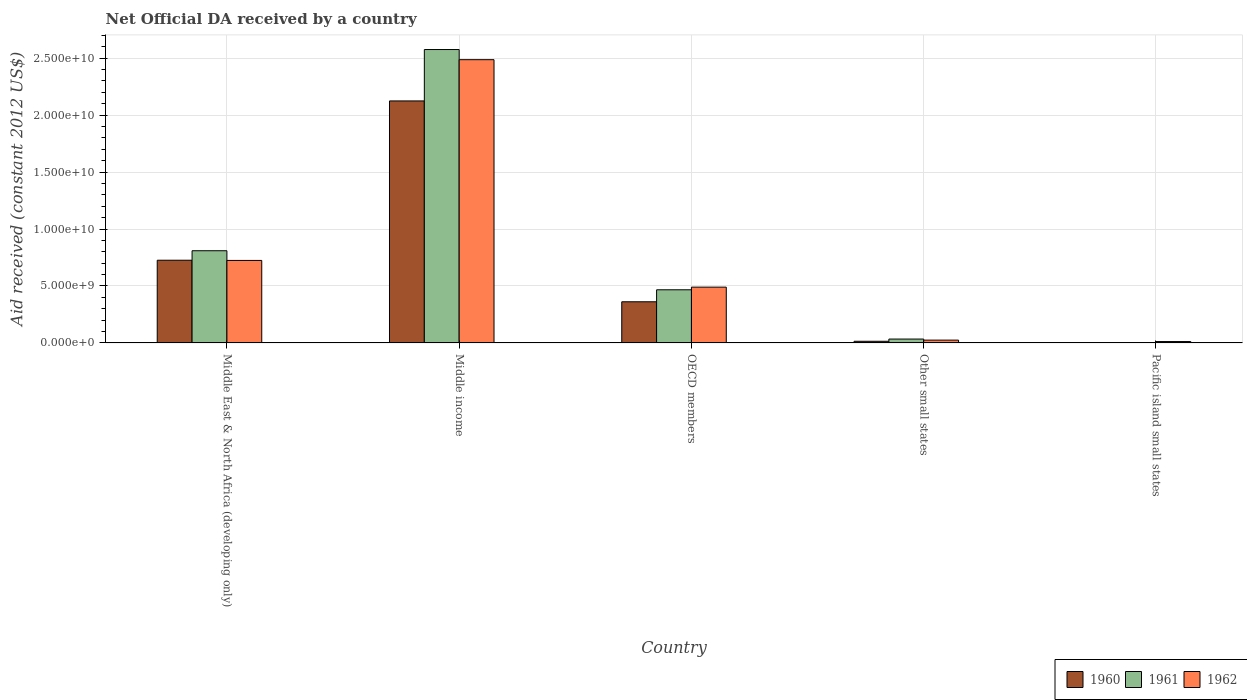Are the number of bars per tick equal to the number of legend labels?
Give a very brief answer. Yes. Are the number of bars on each tick of the X-axis equal?
Your answer should be very brief. Yes. How many bars are there on the 4th tick from the right?
Provide a succinct answer. 3. What is the label of the 2nd group of bars from the left?
Your answer should be very brief. Middle income. What is the net official development assistance aid received in 1960 in Middle East & North Africa (developing only)?
Give a very brief answer. 7.26e+09. Across all countries, what is the maximum net official development assistance aid received in 1960?
Offer a very short reply. 2.12e+1. Across all countries, what is the minimum net official development assistance aid received in 1960?
Your answer should be compact. 2.87e+07. In which country was the net official development assistance aid received in 1962 maximum?
Provide a short and direct response. Middle income. In which country was the net official development assistance aid received in 1960 minimum?
Your response must be concise. Pacific island small states. What is the total net official development assistance aid received in 1961 in the graph?
Keep it short and to the point. 3.89e+1. What is the difference between the net official development assistance aid received in 1960 in OECD members and that in Pacific island small states?
Give a very brief answer. 3.58e+09. What is the difference between the net official development assistance aid received in 1960 in Middle income and the net official development assistance aid received in 1961 in OECD members?
Provide a short and direct response. 1.66e+1. What is the average net official development assistance aid received in 1960 per country?
Keep it short and to the point. 6.46e+09. What is the difference between the net official development assistance aid received of/in 1960 and net official development assistance aid received of/in 1962 in Pacific island small states?
Your response must be concise. -9.36e+07. What is the ratio of the net official development assistance aid received in 1962 in Middle East & North Africa (developing only) to that in Pacific island small states?
Offer a very short reply. 59.23. What is the difference between the highest and the second highest net official development assistance aid received in 1960?
Give a very brief answer. 1.40e+1. What is the difference between the highest and the lowest net official development assistance aid received in 1961?
Keep it short and to the point. 2.57e+1. What does the 1st bar from the left in Pacific island small states represents?
Keep it short and to the point. 1960. Is it the case that in every country, the sum of the net official development assistance aid received in 1962 and net official development assistance aid received in 1960 is greater than the net official development assistance aid received in 1961?
Offer a terse response. Yes. How many bars are there?
Ensure brevity in your answer.  15. Does the graph contain grids?
Offer a terse response. Yes. What is the title of the graph?
Make the answer very short. Net Official DA received by a country. What is the label or title of the Y-axis?
Keep it short and to the point. Aid received (constant 2012 US$). What is the Aid received (constant 2012 US$) of 1960 in Middle East & North Africa (developing only)?
Your response must be concise. 7.26e+09. What is the Aid received (constant 2012 US$) of 1961 in Middle East & North Africa (developing only)?
Your answer should be compact. 8.09e+09. What is the Aid received (constant 2012 US$) of 1962 in Middle East & North Africa (developing only)?
Offer a terse response. 7.24e+09. What is the Aid received (constant 2012 US$) of 1960 in Middle income?
Give a very brief answer. 2.12e+1. What is the Aid received (constant 2012 US$) of 1961 in Middle income?
Make the answer very short. 2.58e+1. What is the Aid received (constant 2012 US$) in 1962 in Middle income?
Offer a terse response. 2.49e+1. What is the Aid received (constant 2012 US$) of 1960 in OECD members?
Ensure brevity in your answer.  3.61e+09. What is the Aid received (constant 2012 US$) of 1961 in OECD members?
Offer a terse response. 4.67e+09. What is the Aid received (constant 2012 US$) in 1962 in OECD members?
Provide a succinct answer. 4.90e+09. What is the Aid received (constant 2012 US$) of 1960 in Other small states?
Your answer should be very brief. 1.46e+08. What is the Aid received (constant 2012 US$) in 1961 in Other small states?
Keep it short and to the point. 3.41e+08. What is the Aid received (constant 2012 US$) of 1962 in Other small states?
Your answer should be compact. 2.48e+08. What is the Aid received (constant 2012 US$) in 1960 in Pacific island small states?
Your answer should be compact. 2.87e+07. What is the Aid received (constant 2012 US$) of 1961 in Pacific island small states?
Ensure brevity in your answer.  3.25e+07. What is the Aid received (constant 2012 US$) of 1962 in Pacific island small states?
Provide a short and direct response. 1.22e+08. Across all countries, what is the maximum Aid received (constant 2012 US$) of 1960?
Keep it short and to the point. 2.12e+1. Across all countries, what is the maximum Aid received (constant 2012 US$) of 1961?
Give a very brief answer. 2.58e+1. Across all countries, what is the maximum Aid received (constant 2012 US$) of 1962?
Make the answer very short. 2.49e+1. Across all countries, what is the minimum Aid received (constant 2012 US$) in 1960?
Offer a very short reply. 2.87e+07. Across all countries, what is the minimum Aid received (constant 2012 US$) of 1961?
Offer a very short reply. 3.25e+07. Across all countries, what is the minimum Aid received (constant 2012 US$) in 1962?
Your response must be concise. 1.22e+08. What is the total Aid received (constant 2012 US$) of 1960 in the graph?
Offer a terse response. 3.23e+1. What is the total Aid received (constant 2012 US$) in 1961 in the graph?
Offer a terse response. 3.89e+1. What is the total Aid received (constant 2012 US$) of 1962 in the graph?
Your response must be concise. 3.74e+1. What is the difference between the Aid received (constant 2012 US$) in 1960 in Middle East & North Africa (developing only) and that in Middle income?
Make the answer very short. -1.40e+1. What is the difference between the Aid received (constant 2012 US$) in 1961 in Middle East & North Africa (developing only) and that in Middle income?
Your response must be concise. -1.77e+1. What is the difference between the Aid received (constant 2012 US$) of 1962 in Middle East & North Africa (developing only) and that in Middle income?
Your answer should be compact. -1.76e+1. What is the difference between the Aid received (constant 2012 US$) in 1960 in Middle East & North Africa (developing only) and that in OECD members?
Provide a succinct answer. 3.65e+09. What is the difference between the Aid received (constant 2012 US$) in 1961 in Middle East & North Africa (developing only) and that in OECD members?
Ensure brevity in your answer.  3.43e+09. What is the difference between the Aid received (constant 2012 US$) of 1962 in Middle East & North Africa (developing only) and that in OECD members?
Ensure brevity in your answer.  2.34e+09. What is the difference between the Aid received (constant 2012 US$) of 1960 in Middle East & North Africa (developing only) and that in Other small states?
Make the answer very short. 7.11e+09. What is the difference between the Aid received (constant 2012 US$) in 1961 in Middle East & North Africa (developing only) and that in Other small states?
Keep it short and to the point. 7.75e+09. What is the difference between the Aid received (constant 2012 US$) of 1962 in Middle East & North Africa (developing only) and that in Other small states?
Provide a short and direct response. 6.99e+09. What is the difference between the Aid received (constant 2012 US$) of 1960 in Middle East & North Africa (developing only) and that in Pacific island small states?
Offer a very short reply. 7.23e+09. What is the difference between the Aid received (constant 2012 US$) in 1961 in Middle East & North Africa (developing only) and that in Pacific island small states?
Make the answer very short. 8.06e+09. What is the difference between the Aid received (constant 2012 US$) in 1962 in Middle East & North Africa (developing only) and that in Pacific island small states?
Provide a short and direct response. 7.12e+09. What is the difference between the Aid received (constant 2012 US$) of 1960 in Middle income and that in OECD members?
Give a very brief answer. 1.76e+1. What is the difference between the Aid received (constant 2012 US$) in 1961 in Middle income and that in OECD members?
Your answer should be very brief. 2.11e+1. What is the difference between the Aid received (constant 2012 US$) of 1962 in Middle income and that in OECD members?
Provide a short and direct response. 2.00e+1. What is the difference between the Aid received (constant 2012 US$) of 1960 in Middle income and that in Other small states?
Provide a short and direct response. 2.11e+1. What is the difference between the Aid received (constant 2012 US$) in 1961 in Middle income and that in Other small states?
Your answer should be compact. 2.54e+1. What is the difference between the Aid received (constant 2012 US$) of 1962 in Middle income and that in Other small states?
Provide a short and direct response. 2.46e+1. What is the difference between the Aid received (constant 2012 US$) of 1960 in Middle income and that in Pacific island small states?
Give a very brief answer. 2.12e+1. What is the difference between the Aid received (constant 2012 US$) in 1961 in Middle income and that in Pacific island small states?
Keep it short and to the point. 2.57e+1. What is the difference between the Aid received (constant 2012 US$) in 1962 in Middle income and that in Pacific island small states?
Your response must be concise. 2.47e+1. What is the difference between the Aid received (constant 2012 US$) in 1960 in OECD members and that in Other small states?
Provide a short and direct response. 3.47e+09. What is the difference between the Aid received (constant 2012 US$) in 1961 in OECD members and that in Other small states?
Keep it short and to the point. 4.32e+09. What is the difference between the Aid received (constant 2012 US$) of 1962 in OECD members and that in Other small states?
Offer a very short reply. 4.65e+09. What is the difference between the Aid received (constant 2012 US$) in 1960 in OECD members and that in Pacific island small states?
Your answer should be compact. 3.58e+09. What is the difference between the Aid received (constant 2012 US$) in 1961 in OECD members and that in Pacific island small states?
Make the answer very short. 4.63e+09. What is the difference between the Aid received (constant 2012 US$) of 1962 in OECD members and that in Pacific island small states?
Keep it short and to the point. 4.78e+09. What is the difference between the Aid received (constant 2012 US$) in 1960 in Other small states and that in Pacific island small states?
Your answer should be compact. 1.17e+08. What is the difference between the Aid received (constant 2012 US$) in 1961 in Other small states and that in Pacific island small states?
Give a very brief answer. 3.09e+08. What is the difference between the Aid received (constant 2012 US$) of 1962 in Other small states and that in Pacific island small states?
Offer a very short reply. 1.26e+08. What is the difference between the Aid received (constant 2012 US$) in 1960 in Middle East & North Africa (developing only) and the Aid received (constant 2012 US$) in 1961 in Middle income?
Keep it short and to the point. -1.85e+1. What is the difference between the Aid received (constant 2012 US$) in 1960 in Middle East & North Africa (developing only) and the Aid received (constant 2012 US$) in 1962 in Middle income?
Offer a very short reply. -1.76e+1. What is the difference between the Aid received (constant 2012 US$) in 1961 in Middle East & North Africa (developing only) and the Aid received (constant 2012 US$) in 1962 in Middle income?
Give a very brief answer. -1.68e+1. What is the difference between the Aid received (constant 2012 US$) of 1960 in Middle East & North Africa (developing only) and the Aid received (constant 2012 US$) of 1961 in OECD members?
Provide a succinct answer. 2.59e+09. What is the difference between the Aid received (constant 2012 US$) of 1960 in Middle East & North Africa (developing only) and the Aid received (constant 2012 US$) of 1962 in OECD members?
Your answer should be very brief. 2.36e+09. What is the difference between the Aid received (constant 2012 US$) of 1961 in Middle East & North Africa (developing only) and the Aid received (constant 2012 US$) of 1962 in OECD members?
Your response must be concise. 3.19e+09. What is the difference between the Aid received (constant 2012 US$) in 1960 in Middle East & North Africa (developing only) and the Aid received (constant 2012 US$) in 1961 in Other small states?
Offer a terse response. 6.92e+09. What is the difference between the Aid received (constant 2012 US$) in 1960 in Middle East & North Africa (developing only) and the Aid received (constant 2012 US$) in 1962 in Other small states?
Your response must be concise. 7.01e+09. What is the difference between the Aid received (constant 2012 US$) in 1961 in Middle East & North Africa (developing only) and the Aid received (constant 2012 US$) in 1962 in Other small states?
Keep it short and to the point. 7.84e+09. What is the difference between the Aid received (constant 2012 US$) of 1960 in Middle East & North Africa (developing only) and the Aid received (constant 2012 US$) of 1961 in Pacific island small states?
Provide a short and direct response. 7.23e+09. What is the difference between the Aid received (constant 2012 US$) of 1960 in Middle East & North Africa (developing only) and the Aid received (constant 2012 US$) of 1962 in Pacific island small states?
Keep it short and to the point. 7.14e+09. What is the difference between the Aid received (constant 2012 US$) in 1961 in Middle East & North Africa (developing only) and the Aid received (constant 2012 US$) in 1962 in Pacific island small states?
Your response must be concise. 7.97e+09. What is the difference between the Aid received (constant 2012 US$) in 1960 in Middle income and the Aid received (constant 2012 US$) in 1961 in OECD members?
Make the answer very short. 1.66e+1. What is the difference between the Aid received (constant 2012 US$) of 1960 in Middle income and the Aid received (constant 2012 US$) of 1962 in OECD members?
Offer a very short reply. 1.63e+1. What is the difference between the Aid received (constant 2012 US$) in 1961 in Middle income and the Aid received (constant 2012 US$) in 1962 in OECD members?
Keep it short and to the point. 2.09e+1. What is the difference between the Aid received (constant 2012 US$) in 1960 in Middle income and the Aid received (constant 2012 US$) in 1961 in Other small states?
Your answer should be very brief. 2.09e+1. What is the difference between the Aid received (constant 2012 US$) of 1960 in Middle income and the Aid received (constant 2012 US$) of 1962 in Other small states?
Your response must be concise. 2.10e+1. What is the difference between the Aid received (constant 2012 US$) of 1961 in Middle income and the Aid received (constant 2012 US$) of 1962 in Other small states?
Ensure brevity in your answer.  2.55e+1. What is the difference between the Aid received (constant 2012 US$) of 1960 in Middle income and the Aid received (constant 2012 US$) of 1961 in Pacific island small states?
Your answer should be very brief. 2.12e+1. What is the difference between the Aid received (constant 2012 US$) of 1960 in Middle income and the Aid received (constant 2012 US$) of 1962 in Pacific island small states?
Ensure brevity in your answer.  2.11e+1. What is the difference between the Aid received (constant 2012 US$) in 1961 in Middle income and the Aid received (constant 2012 US$) in 1962 in Pacific island small states?
Provide a short and direct response. 2.56e+1. What is the difference between the Aid received (constant 2012 US$) of 1960 in OECD members and the Aid received (constant 2012 US$) of 1961 in Other small states?
Keep it short and to the point. 3.27e+09. What is the difference between the Aid received (constant 2012 US$) in 1960 in OECD members and the Aid received (constant 2012 US$) in 1962 in Other small states?
Provide a short and direct response. 3.36e+09. What is the difference between the Aid received (constant 2012 US$) in 1961 in OECD members and the Aid received (constant 2012 US$) in 1962 in Other small states?
Ensure brevity in your answer.  4.42e+09. What is the difference between the Aid received (constant 2012 US$) of 1960 in OECD members and the Aid received (constant 2012 US$) of 1961 in Pacific island small states?
Offer a terse response. 3.58e+09. What is the difference between the Aid received (constant 2012 US$) of 1960 in OECD members and the Aid received (constant 2012 US$) of 1962 in Pacific island small states?
Offer a terse response. 3.49e+09. What is the difference between the Aid received (constant 2012 US$) of 1961 in OECD members and the Aid received (constant 2012 US$) of 1962 in Pacific island small states?
Provide a succinct answer. 4.54e+09. What is the difference between the Aid received (constant 2012 US$) in 1960 in Other small states and the Aid received (constant 2012 US$) in 1961 in Pacific island small states?
Your response must be concise. 1.14e+08. What is the difference between the Aid received (constant 2012 US$) in 1960 in Other small states and the Aid received (constant 2012 US$) in 1962 in Pacific island small states?
Your answer should be very brief. 2.39e+07. What is the difference between the Aid received (constant 2012 US$) of 1961 in Other small states and the Aid received (constant 2012 US$) of 1962 in Pacific island small states?
Provide a short and direct response. 2.19e+08. What is the average Aid received (constant 2012 US$) of 1960 per country?
Provide a short and direct response. 6.46e+09. What is the average Aid received (constant 2012 US$) in 1961 per country?
Ensure brevity in your answer.  7.78e+09. What is the average Aid received (constant 2012 US$) of 1962 per country?
Your response must be concise. 7.47e+09. What is the difference between the Aid received (constant 2012 US$) of 1960 and Aid received (constant 2012 US$) of 1961 in Middle East & North Africa (developing only)?
Your answer should be compact. -8.32e+08. What is the difference between the Aid received (constant 2012 US$) of 1960 and Aid received (constant 2012 US$) of 1962 in Middle East & North Africa (developing only)?
Provide a short and direct response. 1.81e+07. What is the difference between the Aid received (constant 2012 US$) of 1961 and Aid received (constant 2012 US$) of 1962 in Middle East & North Africa (developing only)?
Keep it short and to the point. 8.50e+08. What is the difference between the Aid received (constant 2012 US$) of 1960 and Aid received (constant 2012 US$) of 1961 in Middle income?
Give a very brief answer. -4.51e+09. What is the difference between the Aid received (constant 2012 US$) of 1960 and Aid received (constant 2012 US$) of 1962 in Middle income?
Your answer should be very brief. -3.62e+09. What is the difference between the Aid received (constant 2012 US$) of 1961 and Aid received (constant 2012 US$) of 1962 in Middle income?
Your answer should be very brief. 8.89e+08. What is the difference between the Aid received (constant 2012 US$) of 1960 and Aid received (constant 2012 US$) of 1961 in OECD members?
Keep it short and to the point. -1.05e+09. What is the difference between the Aid received (constant 2012 US$) in 1960 and Aid received (constant 2012 US$) in 1962 in OECD members?
Your response must be concise. -1.28e+09. What is the difference between the Aid received (constant 2012 US$) of 1961 and Aid received (constant 2012 US$) of 1962 in OECD members?
Give a very brief answer. -2.32e+08. What is the difference between the Aid received (constant 2012 US$) in 1960 and Aid received (constant 2012 US$) in 1961 in Other small states?
Your response must be concise. -1.95e+08. What is the difference between the Aid received (constant 2012 US$) of 1960 and Aid received (constant 2012 US$) of 1962 in Other small states?
Make the answer very short. -1.02e+08. What is the difference between the Aid received (constant 2012 US$) in 1961 and Aid received (constant 2012 US$) in 1962 in Other small states?
Provide a short and direct response. 9.32e+07. What is the difference between the Aid received (constant 2012 US$) in 1960 and Aid received (constant 2012 US$) in 1961 in Pacific island small states?
Provide a short and direct response. -3.76e+06. What is the difference between the Aid received (constant 2012 US$) in 1960 and Aid received (constant 2012 US$) in 1962 in Pacific island small states?
Your answer should be very brief. -9.36e+07. What is the difference between the Aid received (constant 2012 US$) of 1961 and Aid received (constant 2012 US$) of 1962 in Pacific island small states?
Keep it short and to the point. -8.98e+07. What is the ratio of the Aid received (constant 2012 US$) of 1960 in Middle East & North Africa (developing only) to that in Middle income?
Offer a terse response. 0.34. What is the ratio of the Aid received (constant 2012 US$) in 1961 in Middle East & North Africa (developing only) to that in Middle income?
Provide a succinct answer. 0.31. What is the ratio of the Aid received (constant 2012 US$) of 1962 in Middle East & North Africa (developing only) to that in Middle income?
Ensure brevity in your answer.  0.29. What is the ratio of the Aid received (constant 2012 US$) in 1960 in Middle East & North Africa (developing only) to that in OECD members?
Provide a short and direct response. 2.01. What is the ratio of the Aid received (constant 2012 US$) in 1961 in Middle East & North Africa (developing only) to that in OECD members?
Provide a succinct answer. 1.73. What is the ratio of the Aid received (constant 2012 US$) in 1962 in Middle East & North Africa (developing only) to that in OECD members?
Ensure brevity in your answer.  1.48. What is the ratio of the Aid received (constant 2012 US$) in 1960 in Middle East & North Africa (developing only) to that in Other small states?
Ensure brevity in your answer.  49.68. What is the ratio of the Aid received (constant 2012 US$) in 1961 in Middle East & North Africa (developing only) to that in Other small states?
Your response must be concise. 23.7. What is the ratio of the Aid received (constant 2012 US$) of 1962 in Middle East & North Africa (developing only) to that in Other small states?
Offer a terse response. 29.18. What is the ratio of the Aid received (constant 2012 US$) in 1960 in Middle East & North Africa (developing only) to that in Pacific island small states?
Provide a short and direct response. 252.89. What is the ratio of the Aid received (constant 2012 US$) in 1961 in Middle East & North Africa (developing only) to that in Pacific island small states?
Provide a short and direct response. 249.23. What is the ratio of the Aid received (constant 2012 US$) of 1962 in Middle East & North Africa (developing only) to that in Pacific island small states?
Give a very brief answer. 59.23. What is the ratio of the Aid received (constant 2012 US$) of 1960 in Middle income to that in OECD members?
Your response must be concise. 5.88. What is the ratio of the Aid received (constant 2012 US$) of 1961 in Middle income to that in OECD members?
Your response must be concise. 5.52. What is the ratio of the Aid received (constant 2012 US$) of 1962 in Middle income to that in OECD members?
Make the answer very short. 5.08. What is the ratio of the Aid received (constant 2012 US$) in 1960 in Middle income to that in Other small states?
Your answer should be very brief. 145.35. What is the ratio of the Aid received (constant 2012 US$) of 1961 in Middle income to that in Other small states?
Provide a short and direct response. 75.42. What is the ratio of the Aid received (constant 2012 US$) of 1962 in Middle income to that in Other small states?
Offer a very short reply. 100.17. What is the ratio of the Aid received (constant 2012 US$) in 1960 in Middle income to that in Pacific island small states?
Your answer should be compact. 739.85. What is the ratio of the Aid received (constant 2012 US$) of 1961 in Middle income to that in Pacific island small states?
Your response must be concise. 793.09. What is the ratio of the Aid received (constant 2012 US$) in 1962 in Middle income to that in Pacific island small states?
Offer a very short reply. 203.34. What is the ratio of the Aid received (constant 2012 US$) in 1960 in OECD members to that in Other small states?
Ensure brevity in your answer.  24.72. What is the ratio of the Aid received (constant 2012 US$) in 1961 in OECD members to that in Other small states?
Your response must be concise. 13.66. What is the ratio of the Aid received (constant 2012 US$) in 1962 in OECD members to that in Other small states?
Your response must be concise. 19.73. What is the ratio of the Aid received (constant 2012 US$) of 1960 in OECD members to that in Pacific island small states?
Your answer should be compact. 125.84. What is the ratio of the Aid received (constant 2012 US$) of 1961 in OECD members to that in Pacific island small states?
Offer a very short reply. 143.69. What is the ratio of the Aid received (constant 2012 US$) of 1962 in OECD members to that in Pacific island small states?
Your answer should be compact. 40.06. What is the ratio of the Aid received (constant 2012 US$) of 1960 in Other small states to that in Pacific island small states?
Your answer should be compact. 5.09. What is the ratio of the Aid received (constant 2012 US$) of 1961 in Other small states to that in Pacific island small states?
Your answer should be compact. 10.52. What is the ratio of the Aid received (constant 2012 US$) in 1962 in Other small states to that in Pacific island small states?
Give a very brief answer. 2.03. What is the difference between the highest and the second highest Aid received (constant 2012 US$) in 1960?
Provide a succinct answer. 1.40e+1. What is the difference between the highest and the second highest Aid received (constant 2012 US$) in 1961?
Give a very brief answer. 1.77e+1. What is the difference between the highest and the second highest Aid received (constant 2012 US$) of 1962?
Offer a very short reply. 1.76e+1. What is the difference between the highest and the lowest Aid received (constant 2012 US$) of 1960?
Your response must be concise. 2.12e+1. What is the difference between the highest and the lowest Aid received (constant 2012 US$) in 1961?
Offer a terse response. 2.57e+1. What is the difference between the highest and the lowest Aid received (constant 2012 US$) in 1962?
Provide a short and direct response. 2.47e+1. 